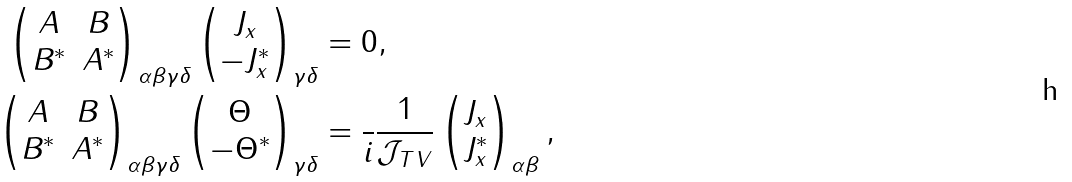Convert formula to latex. <formula><loc_0><loc_0><loc_500><loc_500>\begin{pmatrix} A & B \\ B ^ { * } & A ^ { * } \end{pmatrix} _ { \alpha \beta \gamma \delta } \begin{pmatrix} J _ { x } \\ - J _ { x } ^ { * } \end{pmatrix} _ { \gamma \delta } & = 0 , \\ \begin{pmatrix} A & B \\ B ^ { * } & A ^ { * } \end{pmatrix} _ { \alpha \beta \gamma \delta } \begin{pmatrix} \Theta \\ - \Theta ^ { * } \end{pmatrix} _ { \gamma \delta } & = \frac { } { i } \frac { 1 } { \mathcal { J } _ { T V } } \begin{pmatrix} J _ { x } \\ J _ { x } ^ { * } \end{pmatrix} _ { \alpha \beta } ,</formula> 